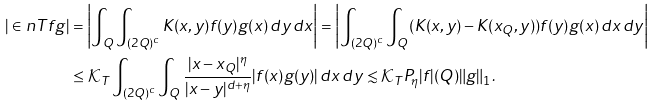Convert formula to latex. <formula><loc_0><loc_0><loc_500><loc_500>| \in n { T f } { g } | & = \left | \int _ { Q } \int _ { ( 2 Q ) ^ { c } } K ( x , y ) f ( y ) g ( x ) \, d y \, d x \right | = \left | \int _ { ( 2 Q ) ^ { c } } \int _ { Q } ( K ( x , y ) - K ( x _ { Q } , y ) ) f ( y ) g ( x ) \, d x \, d y \right | \\ & \leq \mathcal { K } _ { T } \int _ { ( 2 Q ) ^ { c } } \int _ { Q } \frac { | x - x _ { Q } | ^ { \eta } } { | x - y | ^ { d + \eta } } | f ( x ) g ( y ) | \, d x \, d y \lesssim \mathcal { K } _ { T } P _ { \eta } | f | ( Q ) \| g \| _ { 1 } .</formula> 